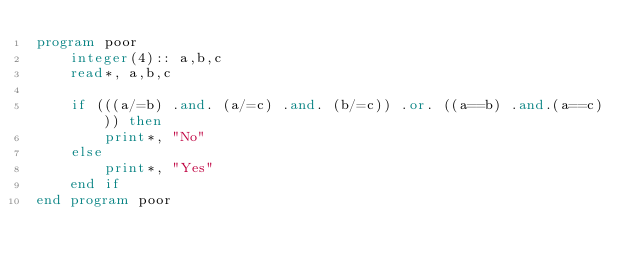Convert code to text. <code><loc_0><loc_0><loc_500><loc_500><_FORTRAN_>program poor
    integer(4):: a,b,c
    read*, a,b,c

    if (((a/=b) .and. (a/=c) .and. (b/=c)) .or. ((a==b) .and.(a==c))) then
        print*, "No"
    else
        print*, "Yes"
    end if
end program poor</code> 